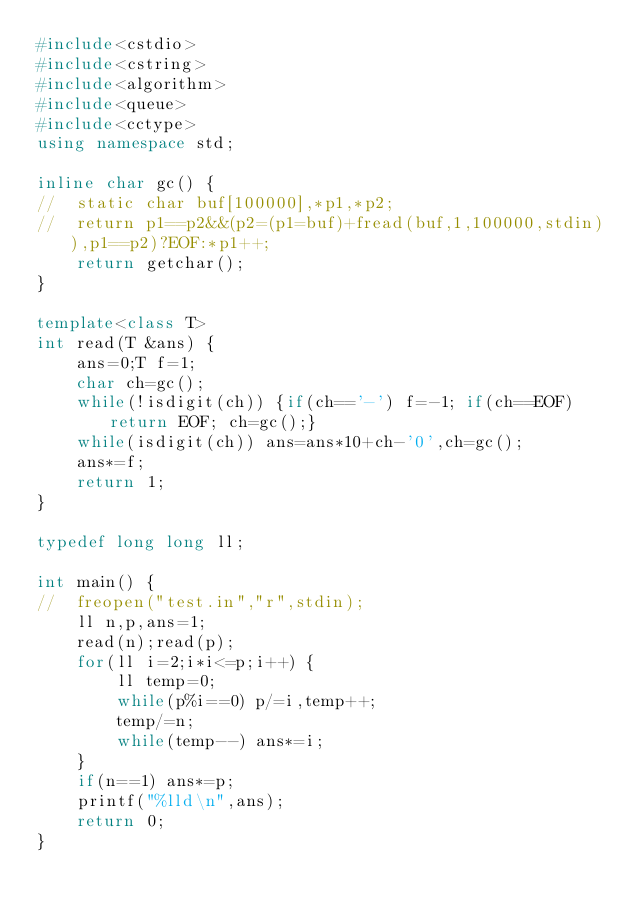Convert code to text. <code><loc_0><loc_0><loc_500><loc_500><_C++_>#include<cstdio>
#include<cstring>
#include<algorithm>
#include<queue>
#include<cctype>
using namespace std;

inline char gc() {
//	static char buf[100000],*p1,*p2;
//	return p1==p2&&(p2=(p1=buf)+fread(buf,1,100000,stdin)),p1==p2)?EOF:*p1++;
	return getchar();
}

template<class T>
int read(T &ans) {
	ans=0;T f=1;
	char ch=gc();
	while(!isdigit(ch)) {if(ch=='-') f=-1; if(ch==EOF) return EOF; ch=gc();}
	while(isdigit(ch)) ans=ans*10+ch-'0',ch=gc();
	ans*=f;
	return 1;
}

typedef long long ll;

int main() {
//	freopen("test.in","r",stdin);
	ll n,p,ans=1;
	read(n);read(p);
	for(ll i=2;i*i<=p;i++) {
		ll temp=0;
		while(p%i==0) p/=i,temp++;
		temp/=n;
		while(temp--) ans*=i;
	}
	if(n==1) ans*=p;
	printf("%lld\n",ans);
	return 0;
}
</code> 